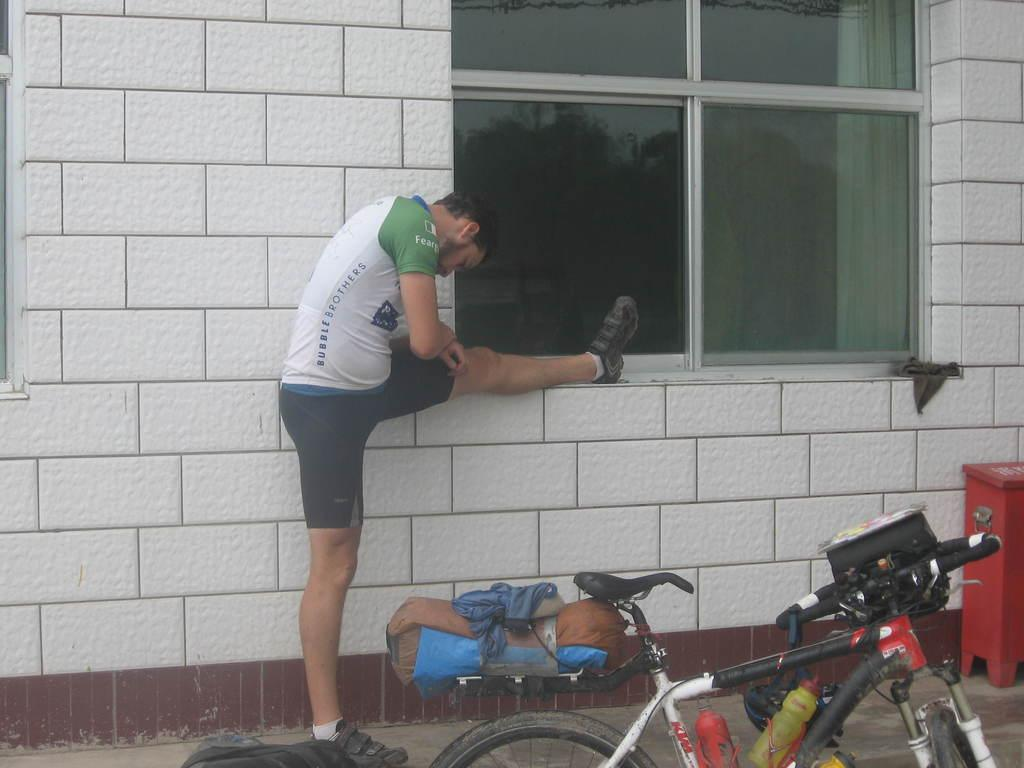What is the main object in the image? There is a bicycle in the image. What else can be seen in the image besides the bicycle? There are two bottles and a person in the image. What can be seen in the background of the image? There is a wall and a window in the background of the image. What type of quicksand can be seen in the image? There is no quicksand present in the image. How does the acoustics of the room affect the sound of the person's voice in the image? There is no information about the acoustics of the room or the person's voice in the image. 